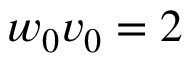Convert formula to latex. <formula><loc_0><loc_0><loc_500><loc_500>w _ { 0 } v _ { 0 } = 2</formula> 